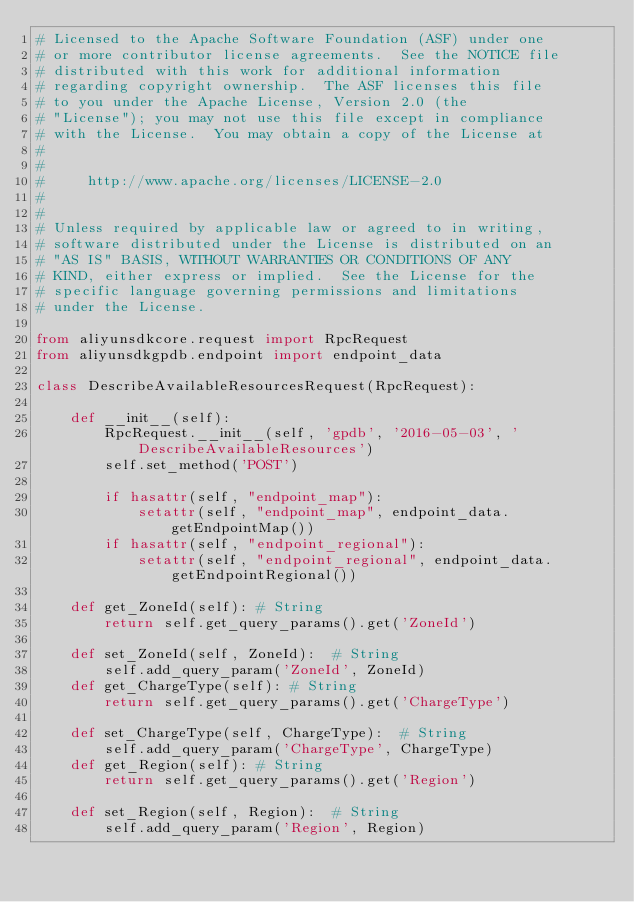Convert code to text. <code><loc_0><loc_0><loc_500><loc_500><_Python_># Licensed to the Apache Software Foundation (ASF) under one
# or more contributor license agreements.  See the NOTICE file
# distributed with this work for additional information
# regarding copyright ownership.  The ASF licenses this file
# to you under the Apache License, Version 2.0 (the
# "License"); you may not use this file except in compliance
# with the License.  You may obtain a copy of the License at
#
#
#     http://www.apache.org/licenses/LICENSE-2.0
#
#
# Unless required by applicable law or agreed to in writing,
# software distributed under the License is distributed on an
# "AS IS" BASIS, WITHOUT WARRANTIES OR CONDITIONS OF ANY
# KIND, either express or implied.  See the License for the
# specific language governing permissions and limitations
# under the License.

from aliyunsdkcore.request import RpcRequest
from aliyunsdkgpdb.endpoint import endpoint_data

class DescribeAvailableResourcesRequest(RpcRequest):

	def __init__(self):
		RpcRequest.__init__(self, 'gpdb', '2016-05-03', 'DescribeAvailableResources')
		self.set_method('POST')

		if hasattr(self, "endpoint_map"):
			setattr(self, "endpoint_map", endpoint_data.getEndpointMap())
		if hasattr(self, "endpoint_regional"):
			setattr(self, "endpoint_regional", endpoint_data.getEndpointRegional())

	def get_ZoneId(self): # String
		return self.get_query_params().get('ZoneId')

	def set_ZoneId(self, ZoneId):  # String
		self.add_query_param('ZoneId', ZoneId)
	def get_ChargeType(self): # String
		return self.get_query_params().get('ChargeType')

	def set_ChargeType(self, ChargeType):  # String
		self.add_query_param('ChargeType', ChargeType)
	def get_Region(self): # String
		return self.get_query_params().get('Region')

	def set_Region(self, Region):  # String
		self.add_query_param('Region', Region)
</code> 